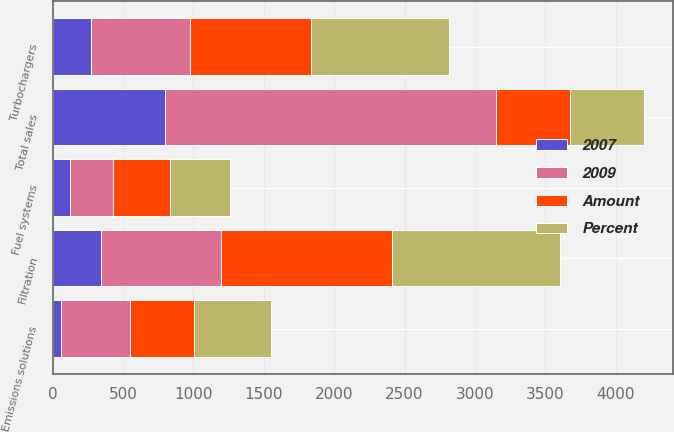Convert chart to OTSL. <chart><loc_0><loc_0><loc_500><loc_500><stacked_bar_chart><ecel><fcel>Filtration<fcel>Turbochargers<fcel>Emissions solutions<fcel>Fuel systems<fcel>Total sales<nl><fcel>2009<fcel>851<fcel>704<fcel>495<fcel>305<fcel>2355<nl><fcel>Percent<fcel>1194<fcel>979<fcel>553<fcel>426<fcel>524<nl><fcel>Amount<fcel>1215<fcel>860<fcel>448<fcel>409<fcel>524<nl><fcel>2007<fcel>343<fcel>275<fcel>58<fcel>121<fcel>797<nl></chart> 